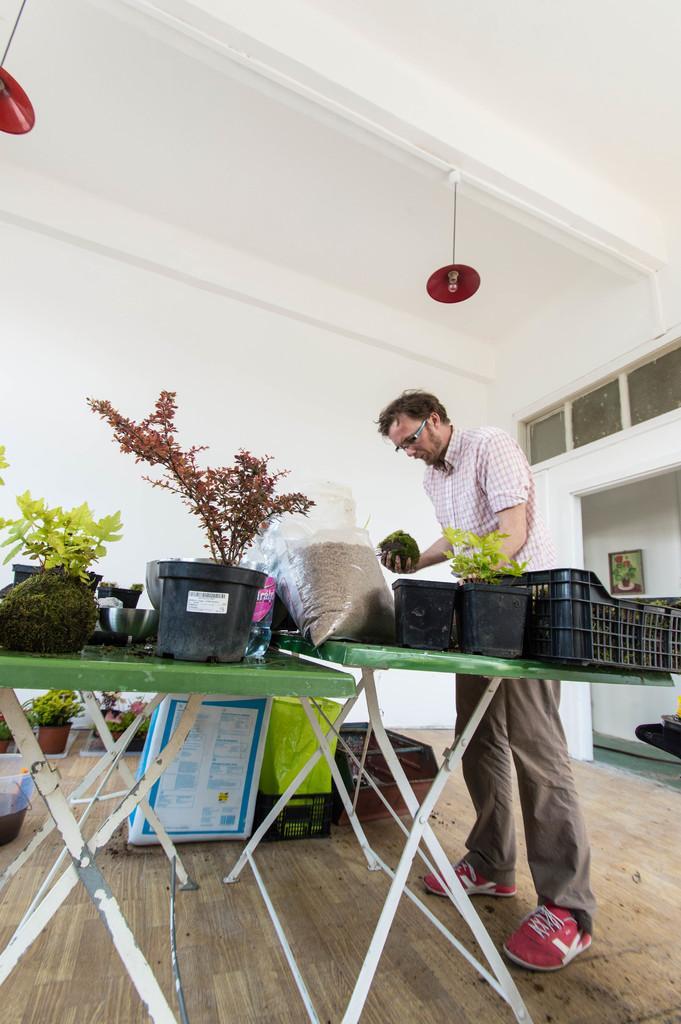Could you give a brief overview of what you see in this image? In the picture we can see inside the house with a man standing near the two tables on the tables we can see some plants and a polythene bag of sand and on the other table, we can see some other plants and on the floor, we can see some plants and in the background we can see a wall with a photo frame and the painting in it. 